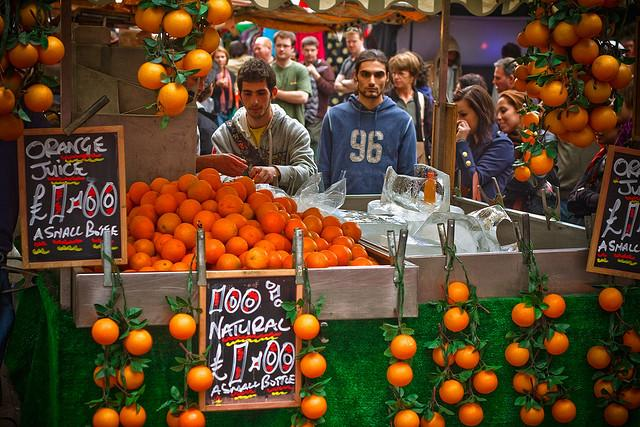What are they waiting in line for? orange juice 